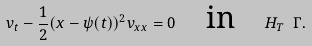<formula> <loc_0><loc_0><loc_500><loc_500>v _ { t } - \frac { 1 } { 2 } ( x - \psi ( t ) ) ^ { 2 } v _ { x x } = 0 \quad \text {in} \quad H _ { T } \ \Gamma .</formula> 